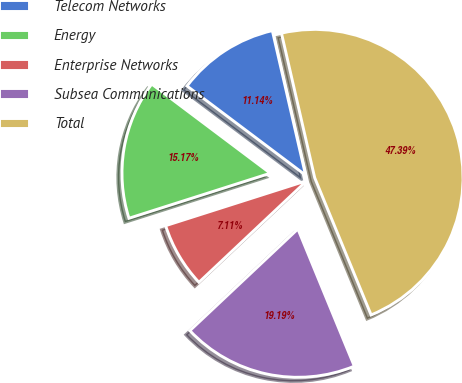<chart> <loc_0><loc_0><loc_500><loc_500><pie_chart><fcel>Telecom Networks<fcel>Energy<fcel>Enterprise Networks<fcel>Subsea Communications<fcel>Total<nl><fcel>11.14%<fcel>15.17%<fcel>7.11%<fcel>19.19%<fcel>47.39%<nl></chart> 